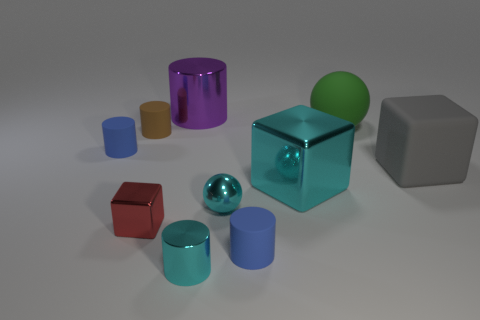Is the size of the rubber block the same as the blue thing right of the tiny brown cylinder?
Your response must be concise. No. Are there any small blue cylinders that are on the left side of the small matte cylinder that is in front of the big shiny thing that is in front of the tiny brown cylinder?
Offer a terse response. Yes. What is the material of the tiny object that is in front of the tiny blue rubber cylinder right of the red block?
Your answer should be very brief. Metal. There is a block that is on the left side of the big gray block and right of the large purple cylinder; what is its material?
Provide a short and direct response. Metal. Is there a brown object that has the same shape as the tiny red shiny object?
Ensure brevity in your answer.  No. Is there a blue matte thing that is to the right of the blue thing on the right side of the purple metal thing?
Offer a terse response. No. What number of large purple things have the same material as the tiny brown cylinder?
Your answer should be compact. 0. Is there a big purple block?
Offer a very short reply. No. How many metal things have the same color as the small shiny ball?
Give a very brief answer. 2. Is the material of the small red cube the same as the big object that is on the right side of the green rubber thing?
Your response must be concise. No. 